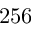<formula> <loc_0><loc_0><loc_500><loc_500>2 5 6</formula> 